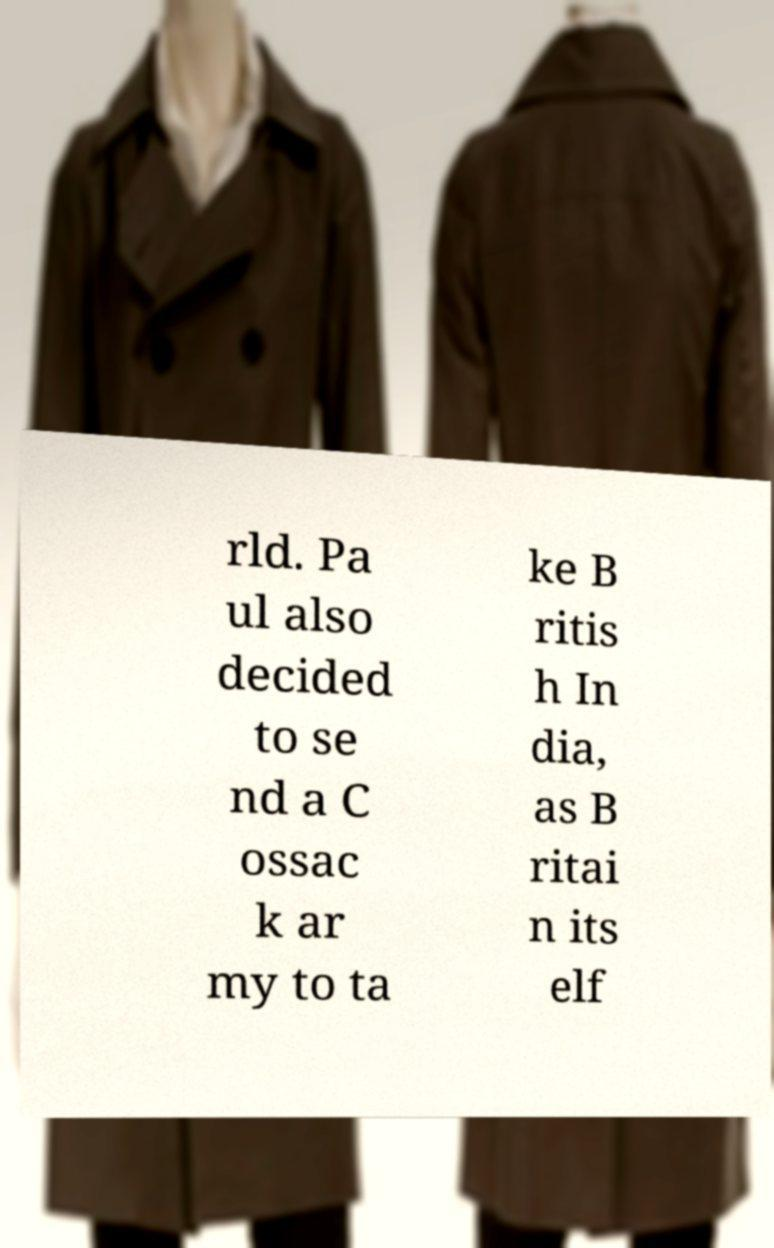Can you read and provide the text displayed in the image?This photo seems to have some interesting text. Can you extract and type it out for me? rld. Pa ul also decided to se nd a C ossac k ar my to ta ke B ritis h In dia, as B ritai n its elf 